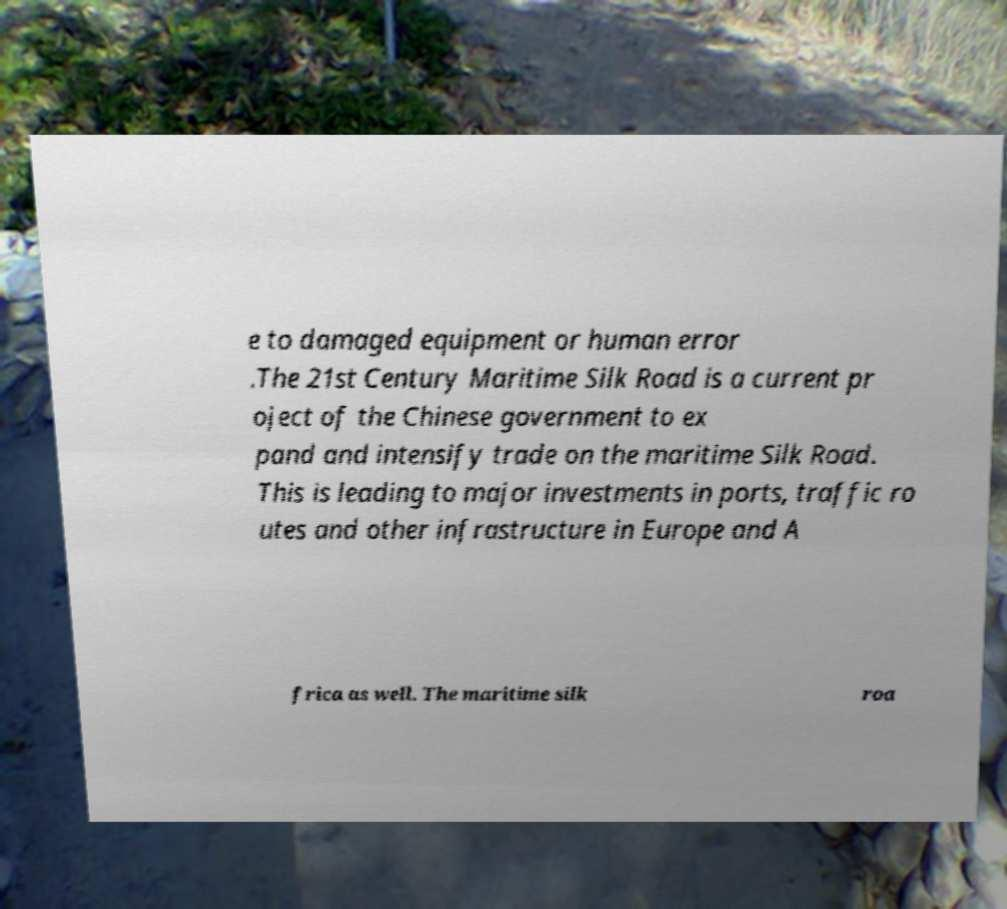For documentation purposes, I need the text within this image transcribed. Could you provide that? e to damaged equipment or human error .The 21st Century Maritime Silk Road is a current pr oject of the Chinese government to ex pand and intensify trade on the maritime Silk Road. This is leading to major investments in ports, traffic ro utes and other infrastructure in Europe and A frica as well. The maritime silk roa 